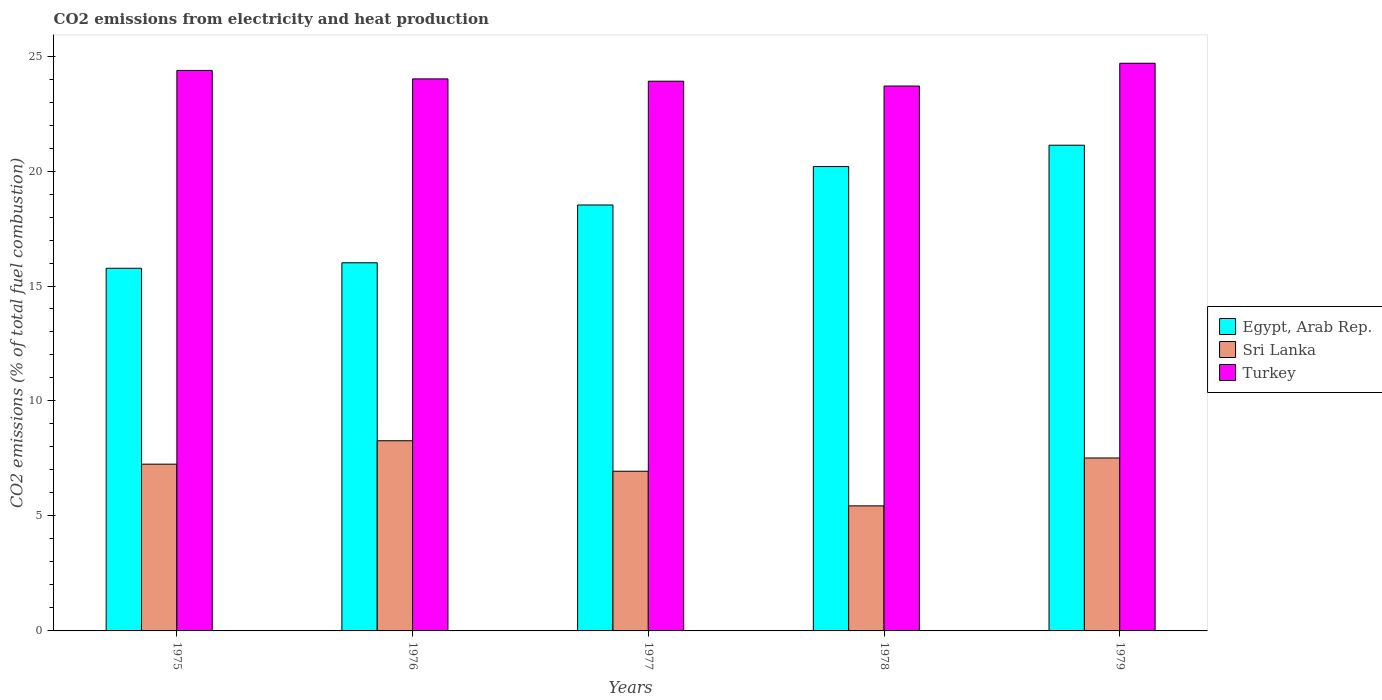Are the number of bars on each tick of the X-axis equal?
Your response must be concise. Yes. What is the label of the 2nd group of bars from the left?
Make the answer very short. 1976. What is the amount of CO2 emitted in Sri Lanka in 1979?
Ensure brevity in your answer.  7.52. Across all years, what is the maximum amount of CO2 emitted in Turkey?
Keep it short and to the point. 24.69. Across all years, what is the minimum amount of CO2 emitted in Turkey?
Provide a succinct answer. 23.7. In which year was the amount of CO2 emitted in Egypt, Arab Rep. maximum?
Ensure brevity in your answer.  1979. In which year was the amount of CO2 emitted in Turkey minimum?
Give a very brief answer. 1978. What is the total amount of CO2 emitted in Turkey in the graph?
Keep it short and to the point. 120.67. What is the difference between the amount of CO2 emitted in Turkey in 1976 and that in 1977?
Make the answer very short. 0.1. What is the difference between the amount of CO2 emitted in Egypt, Arab Rep. in 1977 and the amount of CO2 emitted in Sri Lanka in 1978?
Provide a succinct answer. 13.08. What is the average amount of CO2 emitted in Turkey per year?
Provide a short and direct response. 24.13. In the year 1975, what is the difference between the amount of CO2 emitted in Turkey and amount of CO2 emitted in Sri Lanka?
Ensure brevity in your answer.  17.12. What is the ratio of the amount of CO2 emitted in Egypt, Arab Rep. in 1977 to that in 1979?
Make the answer very short. 0.88. Is the amount of CO2 emitted in Sri Lanka in 1977 less than that in 1979?
Your answer should be very brief. Yes. What is the difference between the highest and the second highest amount of CO2 emitted in Sri Lanka?
Make the answer very short. 0.75. What is the difference between the highest and the lowest amount of CO2 emitted in Egypt, Arab Rep.?
Make the answer very short. 5.35. In how many years, is the amount of CO2 emitted in Egypt, Arab Rep. greater than the average amount of CO2 emitted in Egypt, Arab Rep. taken over all years?
Make the answer very short. 3. What does the 1st bar from the left in 1975 represents?
Ensure brevity in your answer.  Egypt, Arab Rep. Does the graph contain any zero values?
Ensure brevity in your answer.  No. Does the graph contain grids?
Provide a short and direct response. No. Where does the legend appear in the graph?
Offer a very short reply. Center right. How are the legend labels stacked?
Make the answer very short. Vertical. What is the title of the graph?
Make the answer very short. CO2 emissions from electricity and heat production. What is the label or title of the X-axis?
Provide a succinct answer. Years. What is the label or title of the Y-axis?
Your answer should be compact. CO2 emissions (% of total fuel combustion). What is the CO2 emissions (% of total fuel combustion) of Egypt, Arab Rep. in 1975?
Give a very brief answer. 15.77. What is the CO2 emissions (% of total fuel combustion) in Sri Lanka in 1975?
Ensure brevity in your answer.  7.25. What is the CO2 emissions (% of total fuel combustion) in Turkey in 1975?
Provide a short and direct response. 24.38. What is the CO2 emissions (% of total fuel combustion) in Egypt, Arab Rep. in 1976?
Your response must be concise. 16.01. What is the CO2 emissions (% of total fuel combustion) of Sri Lanka in 1976?
Provide a succinct answer. 8.27. What is the CO2 emissions (% of total fuel combustion) in Turkey in 1976?
Offer a very short reply. 24.01. What is the CO2 emissions (% of total fuel combustion) in Egypt, Arab Rep. in 1977?
Provide a succinct answer. 18.52. What is the CO2 emissions (% of total fuel combustion) of Sri Lanka in 1977?
Give a very brief answer. 6.94. What is the CO2 emissions (% of total fuel combustion) in Turkey in 1977?
Offer a terse response. 23.91. What is the CO2 emissions (% of total fuel combustion) in Egypt, Arab Rep. in 1978?
Your answer should be very brief. 20.19. What is the CO2 emissions (% of total fuel combustion) of Sri Lanka in 1978?
Offer a very short reply. 5.44. What is the CO2 emissions (% of total fuel combustion) of Turkey in 1978?
Your answer should be very brief. 23.7. What is the CO2 emissions (% of total fuel combustion) of Egypt, Arab Rep. in 1979?
Offer a very short reply. 21.12. What is the CO2 emissions (% of total fuel combustion) of Sri Lanka in 1979?
Your answer should be very brief. 7.52. What is the CO2 emissions (% of total fuel combustion) of Turkey in 1979?
Your answer should be compact. 24.69. Across all years, what is the maximum CO2 emissions (% of total fuel combustion) in Egypt, Arab Rep.?
Your answer should be compact. 21.12. Across all years, what is the maximum CO2 emissions (% of total fuel combustion) of Sri Lanka?
Your answer should be compact. 8.27. Across all years, what is the maximum CO2 emissions (% of total fuel combustion) in Turkey?
Your answer should be very brief. 24.69. Across all years, what is the minimum CO2 emissions (% of total fuel combustion) in Egypt, Arab Rep.?
Give a very brief answer. 15.77. Across all years, what is the minimum CO2 emissions (% of total fuel combustion) in Sri Lanka?
Ensure brevity in your answer.  5.44. Across all years, what is the minimum CO2 emissions (% of total fuel combustion) in Turkey?
Give a very brief answer. 23.7. What is the total CO2 emissions (% of total fuel combustion) of Egypt, Arab Rep. in the graph?
Your response must be concise. 91.62. What is the total CO2 emissions (% of total fuel combustion) in Sri Lanka in the graph?
Offer a very short reply. 35.43. What is the total CO2 emissions (% of total fuel combustion) in Turkey in the graph?
Make the answer very short. 120.67. What is the difference between the CO2 emissions (% of total fuel combustion) in Egypt, Arab Rep. in 1975 and that in 1976?
Provide a succinct answer. -0.24. What is the difference between the CO2 emissions (% of total fuel combustion) in Sri Lanka in 1975 and that in 1976?
Offer a very short reply. -1.02. What is the difference between the CO2 emissions (% of total fuel combustion) of Turkey in 1975 and that in 1976?
Your answer should be very brief. 0.37. What is the difference between the CO2 emissions (% of total fuel combustion) of Egypt, Arab Rep. in 1975 and that in 1977?
Make the answer very short. -2.75. What is the difference between the CO2 emissions (% of total fuel combustion) in Sri Lanka in 1975 and that in 1977?
Offer a terse response. 0.31. What is the difference between the CO2 emissions (% of total fuel combustion) in Turkey in 1975 and that in 1977?
Your answer should be compact. 0.47. What is the difference between the CO2 emissions (% of total fuel combustion) in Egypt, Arab Rep. in 1975 and that in 1978?
Provide a succinct answer. -4.42. What is the difference between the CO2 emissions (% of total fuel combustion) in Sri Lanka in 1975 and that in 1978?
Your response must be concise. 1.81. What is the difference between the CO2 emissions (% of total fuel combustion) in Turkey in 1975 and that in 1978?
Your response must be concise. 0.68. What is the difference between the CO2 emissions (% of total fuel combustion) in Egypt, Arab Rep. in 1975 and that in 1979?
Give a very brief answer. -5.35. What is the difference between the CO2 emissions (% of total fuel combustion) in Sri Lanka in 1975 and that in 1979?
Your answer should be very brief. -0.27. What is the difference between the CO2 emissions (% of total fuel combustion) of Turkey in 1975 and that in 1979?
Ensure brevity in your answer.  -0.31. What is the difference between the CO2 emissions (% of total fuel combustion) in Egypt, Arab Rep. in 1976 and that in 1977?
Keep it short and to the point. -2.51. What is the difference between the CO2 emissions (% of total fuel combustion) in Sri Lanka in 1976 and that in 1977?
Ensure brevity in your answer.  1.33. What is the difference between the CO2 emissions (% of total fuel combustion) in Turkey in 1976 and that in 1977?
Give a very brief answer. 0.1. What is the difference between the CO2 emissions (% of total fuel combustion) of Egypt, Arab Rep. in 1976 and that in 1978?
Your answer should be compact. -4.19. What is the difference between the CO2 emissions (% of total fuel combustion) in Sri Lanka in 1976 and that in 1978?
Offer a terse response. 2.83. What is the difference between the CO2 emissions (% of total fuel combustion) of Turkey in 1976 and that in 1978?
Keep it short and to the point. 0.31. What is the difference between the CO2 emissions (% of total fuel combustion) of Egypt, Arab Rep. in 1976 and that in 1979?
Make the answer very short. -5.11. What is the difference between the CO2 emissions (% of total fuel combustion) in Sri Lanka in 1976 and that in 1979?
Ensure brevity in your answer.  0.75. What is the difference between the CO2 emissions (% of total fuel combustion) in Turkey in 1976 and that in 1979?
Ensure brevity in your answer.  -0.68. What is the difference between the CO2 emissions (% of total fuel combustion) in Egypt, Arab Rep. in 1977 and that in 1978?
Offer a terse response. -1.67. What is the difference between the CO2 emissions (% of total fuel combustion) in Sri Lanka in 1977 and that in 1978?
Your answer should be very brief. 1.51. What is the difference between the CO2 emissions (% of total fuel combustion) of Turkey in 1977 and that in 1978?
Ensure brevity in your answer.  0.21. What is the difference between the CO2 emissions (% of total fuel combustion) in Egypt, Arab Rep. in 1977 and that in 1979?
Provide a succinct answer. -2.6. What is the difference between the CO2 emissions (% of total fuel combustion) in Sri Lanka in 1977 and that in 1979?
Give a very brief answer. -0.58. What is the difference between the CO2 emissions (% of total fuel combustion) of Turkey in 1977 and that in 1979?
Ensure brevity in your answer.  -0.78. What is the difference between the CO2 emissions (% of total fuel combustion) of Egypt, Arab Rep. in 1978 and that in 1979?
Offer a very short reply. -0.93. What is the difference between the CO2 emissions (% of total fuel combustion) in Sri Lanka in 1978 and that in 1979?
Keep it short and to the point. -2.08. What is the difference between the CO2 emissions (% of total fuel combustion) in Turkey in 1978 and that in 1979?
Provide a succinct answer. -0.99. What is the difference between the CO2 emissions (% of total fuel combustion) of Egypt, Arab Rep. in 1975 and the CO2 emissions (% of total fuel combustion) of Sri Lanka in 1976?
Your answer should be very brief. 7.5. What is the difference between the CO2 emissions (% of total fuel combustion) of Egypt, Arab Rep. in 1975 and the CO2 emissions (% of total fuel combustion) of Turkey in 1976?
Provide a short and direct response. -8.24. What is the difference between the CO2 emissions (% of total fuel combustion) of Sri Lanka in 1975 and the CO2 emissions (% of total fuel combustion) of Turkey in 1976?
Your response must be concise. -16.76. What is the difference between the CO2 emissions (% of total fuel combustion) in Egypt, Arab Rep. in 1975 and the CO2 emissions (% of total fuel combustion) in Sri Lanka in 1977?
Provide a succinct answer. 8.83. What is the difference between the CO2 emissions (% of total fuel combustion) in Egypt, Arab Rep. in 1975 and the CO2 emissions (% of total fuel combustion) in Turkey in 1977?
Offer a terse response. -8.14. What is the difference between the CO2 emissions (% of total fuel combustion) of Sri Lanka in 1975 and the CO2 emissions (% of total fuel combustion) of Turkey in 1977?
Offer a very short reply. -16.65. What is the difference between the CO2 emissions (% of total fuel combustion) in Egypt, Arab Rep. in 1975 and the CO2 emissions (% of total fuel combustion) in Sri Lanka in 1978?
Your response must be concise. 10.33. What is the difference between the CO2 emissions (% of total fuel combustion) in Egypt, Arab Rep. in 1975 and the CO2 emissions (% of total fuel combustion) in Turkey in 1978?
Your answer should be compact. -7.93. What is the difference between the CO2 emissions (% of total fuel combustion) of Sri Lanka in 1975 and the CO2 emissions (% of total fuel combustion) of Turkey in 1978?
Offer a very short reply. -16.44. What is the difference between the CO2 emissions (% of total fuel combustion) in Egypt, Arab Rep. in 1975 and the CO2 emissions (% of total fuel combustion) in Sri Lanka in 1979?
Offer a very short reply. 8.25. What is the difference between the CO2 emissions (% of total fuel combustion) in Egypt, Arab Rep. in 1975 and the CO2 emissions (% of total fuel combustion) in Turkey in 1979?
Provide a short and direct response. -8.92. What is the difference between the CO2 emissions (% of total fuel combustion) of Sri Lanka in 1975 and the CO2 emissions (% of total fuel combustion) of Turkey in 1979?
Offer a terse response. -17.43. What is the difference between the CO2 emissions (% of total fuel combustion) of Egypt, Arab Rep. in 1976 and the CO2 emissions (% of total fuel combustion) of Sri Lanka in 1977?
Keep it short and to the point. 9.06. What is the difference between the CO2 emissions (% of total fuel combustion) in Egypt, Arab Rep. in 1976 and the CO2 emissions (% of total fuel combustion) in Turkey in 1977?
Provide a short and direct response. -7.9. What is the difference between the CO2 emissions (% of total fuel combustion) in Sri Lanka in 1976 and the CO2 emissions (% of total fuel combustion) in Turkey in 1977?
Keep it short and to the point. -15.64. What is the difference between the CO2 emissions (% of total fuel combustion) of Egypt, Arab Rep. in 1976 and the CO2 emissions (% of total fuel combustion) of Sri Lanka in 1978?
Ensure brevity in your answer.  10.57. What is the difference between the CO2 emissions (% of total fuel combustion) of Egypt, Arab Rep. in 1976 and the CO2 emissions (% of total fuel combustion) of Turkey in 1978?
Offer a terse response. -7.69. What is the difference between the CO2 emissions (% of total fuel combustion) of Sri Lanka in 1976 and the CO2 emissions (% of total fuel combustion) of Turkey in 1978?
Make the answer very short. -15.43. What is the difference between the CO2 emissions (% of total fuel combustion) in Egypt, Arab Rep. in 1976 and the CO2 emissions (% of total fuel combustion) in Sri Lanka in 1979?
Provide a succinct answer. 8.49. What is the difference between the CO2 emissions (% of total fuel combustion) in Egypt, Arab Rep. in 1976 and the CO2 emissions (% of total fuel combustion) in Turkey in 1979?
Ensure brevity in your answer.  -8.68. What is the difference between the CO2 emissions (% of total fuel combustion) of Sri Lanka in 1976 and the CO2 emissions (% of total fuel combustion) of Turkey in 1979?
Your response must be concise. -16.42. What is the difference between the CO2 emissions (% of total fuel combustion) of Egypt, Arab Rep. in 1977 and the CO2 emissions (% of total fuel combustion) of Sri Lanka in 1978?
Your response must be concise. 13.09. What is the difference between the CO2 emissions (% of total fuel combustion) of Egypt, Arab Rep. in 1977 and the CO2 emissions (% of total fuel combustion) of Turkey in 1978?
Provide a short and direct response. -5.17. What is the difference between the CO2 emissions (% of total fuel combustion) of Sri Lanka in 1977 and the CO2 emissions (% of total fuel combustion) of Turkey in 1978?
Offer a very short reply. -16.75. What is the difference between the CO2 emissions (% of total fuel combustion) of Egypt, Arab Rep. in 1977 and the CO2 emissions (% of total fuel combustion) of Sri Lanka in 1979?
Your answer should be very brief. 11. What is the difference between the CO2 emissions (% of total fuel combustion) of Egypt, Arab Rep. in 1977 and the CO2 emissions (% of total fuel combustion) of Turkey in 1979?
Your answer should be compact. -6.16. What is the difference between the CO2 emissions (% of total fuel combustion) of Sri Lanka in 1977 and the CO2 emissions (% of total fuel combustion) of Turkey in 1979?
Keep it short and to the point. -17.74. What is the difference between the CO2 emissions (% of total fuel combustion) in Egypt, Arab Rep. in 1978 and the CO2 emissions (% of total fuel combustion) in Sri Lanka in 1979?
Provide a short and direct response. 12.67. What is the difference between the CO2 emissions (% of total fuel combustion) of Egypt, Arab Rep. in 1978 and the CO2 emissions (% of total fuel combustion) of Turkey in 1979?
Offer a very short reply. -4.49. What is the difference between the CO2 emissions (% of total fuel combustion) of Sri Lanka in 1978 and the CO2 emissions (% of total fuel combustion) of Turkey in 1979?
Your answer should be compact. -19.25. What is the average CO2 emissions (% of total fuel combustion) of Egypt, Arab Rep. per year?
Offer a very short reply. 18.32. What is the average CO2 emissions (% of total fuel combustion) in Sri Lanka per year?
Offer a very short reply. 7.09. What is the average CO2 emissions (% of total fuel combustion) in Turkey per year?
Your answer should be compact. 24.13. In the year 1975, what is the difference between the CO2 emissions (% of total fuel combustion) in Egypt, Arab Rep. and CO2 emissions (% of total fuel combustion) in Sri Lanka?
Provide a succinct answer. 8.52. In the year 1975, what is the difference between the CO2 emissions (% of total fuel combustion) of Egypt, Arab Rep. and CO2 emissions (% of total fuel combustion) of Turkey?
Give a very brief answer. -8.6. In the year 1975, what is the difference between the CO2 emissions (% of total fuel combustion) in Sri Lanka and CO2 emissions (% of total fuel combustion) in Turkey?
Ensure brevity in your answer.  -17.12. In the year 1976, what is the difference between the CO2 emissions (% of total fuel combustion) of Egypt, Arab Rep. and CO2 emissions (% of total fuel combustion) of Sri Lanka?
Provide a short and direct response. 7.74. In the year 1976, what is the difference between the CO2 emissions (% of total fuel combustion) in Egypt, Arab Rep. and CO2 emissions (% of total fuel combustion) in Turkey?
Offer a very short reply. -8. In the year 1976, what is the difference between the CO2 emissions (% of total fuel combustion) of Sri Lanka and CO2 emissions (% of total fuel combustion) of Turkey?
Make the answer very short. -15.74. In the year 1977, what is the difference between the CO2 emissions (% of total fuel combustion) of Egypt, Arab Rep. and CO2 emissions (% of total fuel combustion) of Sri Lanka?
Your response must be concise. 11.58. In the year 1977, what is the difference between the CO2 emissions (% of total fuel combustion) of Egypt, Arab Rep. and CO2 emissions (% of total fuel combustion) of Turkey?
Offer a very short reply. -5.38. In the year 1977, what is the difference between the CO2 emissions (% of total fuel combustion) in Sri Lanka and CO2 emissions (% of total fuel combustion) in Turkey?
Your response must be concise. -16.96. In the year 1978, what is the difference between the CO2 emissions (% of total fuel combustion) of Egypt, Arab Rep. and CO2 emissions (% of total fuel combustion) of Sri Lanka?
Your response must be concise. 14.76. In the year 1978, what is the difference between the CO2 emissions (% of total fuel combustion) of Egypt, Arab Rep. and CO2 emissions (% of total fuel combustion) of Turkey?
Your answer should be compact. -3.5. In the year 1978, what is the difference between the CO2 emissions (% of total fuel combustion) in Sri Lanka and CO2 emissions (% of total fuel combustion) in Turkey?
Your response must be concise. -18.26. In the year 1979, what is the difference between the CO2 emissions (% of total fuel combustion) of Egypt, Arab Rep. and CO2 emissions (% of total fuel combustion) of Sri Lanka?
Give a very brief answer. 13.6. In the year 1979, what is the difference between the CO2 emissions (% of total fuel combustion) of Egypt, Arab Rep. and CO2 emissions (% of total fuel combustion) of Turkey?
Give a very brief answer. -3.56. In the year 1979, what is the difference between the CO2 emissions (% of total fuel combustion) of Sri Lanka and CO2 emissions (% of total fuel combustion) of Turkey?
Your response must be concise. -17.17. What is the ratio of the CO2 emissions (% of total fuel combustion) of Egypt, Arab Rep. in 1975 to that in 1976?
Provide a succinct answer. 0.99. What is the ratio of the CO2 emissions (% of total fuel combustion) in Sri Lanka in 1975 to that in 1976?
Ensure brevity in your answer.  0.88. What is the ratio of the CO2 emissions (% of total fuel combustion) in Turkey in 1975 to that in 1976?
Your answer should be compact. 1.02. What is the ratio of the CO2 emissions (% of total fuel combustion) in Egypt, Arab Rep. in 1975 to that in 1977?
Provide a short and direct response. 0.85. What is the ratio of the CO2 emissions (% of total fuel combustion) of Sri Lanka in 1975 to that in 1977?
Keep it short and to the point. 1.04. What is the ratio of the CO2 emissions (% of total fuel combustion) of Turkey in 1975 to that in 1977?
Ensure brevity in your answer.  1.02. What is the ratio of the CO2 emissions (% of total fuel combustion) in Egypt, Arab Rep. in 1975 to that in 1978?
Keep it short and to the point. 0.78. What is the ratio of the CO2 emissions (% of total fuel combustion) in Sri Lanka in 1975 to that in 1978?
Your answer should be compact. 1.33. What is the ratio of the CO2 emissions (% of total fuel combustion) in Turkey in 1975 to that in 1978?
Provide a succinct answer. 1.03. What is the ratio of the CO2 emissions (% of total fuel combustion) in Egypt, Arab Rep. in 1975 to that in 1979?
Provide a succinct answer. 0.75. What is the ratio of the CO2 emissions (% of total fuel combustion) of Sri Lanka in 1975 to that in 1979?
Provide a succinct answer. 0.96. What is the ratio of the CO2 emissions (% of total fuel combustion) of Turkey in 1975 to that in 1979?
Offer a terse response. 0.99. What is the ratio of the CO2 emissions (% of total fuel combustion) in Egypt, Arab Rep. in 1976 to that in 1977?
Your answer should be compact. 0.86. What is the ratio of the CO2 emissions (% of total fuel combustion) in Sri Lanka in 1976 to that in 1977?
Give a very brief answer. 1.19. What is the ratio of the CO2 emissions (% of total fuel combustion) of Egypt, Arab Rep. in 1976 to that in 1978?
Your answer should be very brief. 0.79. What is the ratio of the CO2 emissions (% of total fuel combustion) of Sri Lanka in 1976 to that in 1978?
Offer a very short reply. 1.52. What is the ratio of the CO2 emissions (% of total fuel combustion) of Turkey in 1976 to that in 1978?
Your answer should be compact. 1.01. What is the ratio of the CO2 emissions (% of total fuel combustion) of Egypt, Arab Rep. in 1976 to that in 1979?
Your answer should be compact. 0.76. What is the ratio of the CO2 emissions (% of total fuel combustion) in Sri Lanka in 1976 to that in 1979?
Offer a terse response. 1.1. What is the ratio of the CO2 emissions (% of total fuel combustion) in Turkey in 1976 to that in 1979?
Offer a terse response. 0.97. What is the ratio of the CO2 emissions (% of total fuel combustion) in Egypt, Arab Rep. in 1977 to that in 1978?
Offer a terse response. 0.92. What is the ratio of the CO2 emissions (% of total fuel combustion) in Sri Lanka in 1977 to that in 1978?
Keep it short and to the point. 1.28. What is the ratio of the CO2 emissions (% of total fuel combustion) of Turkey in 1977 to that in 1978?
Ensure brevity in your answer.  1.01. What is the ratio of the CO2 emissions (% of total fuel combustion) of Egypt, Arab Rep. in 1977 to that in 1979?
Provide a succinct answer. 0.88. What is the ratio of the CO2 emissions (% of total fuel combustion) in Sri Lanka in 1977 to that in 1979?
Ensure brevity in your answer.  0.92. What is the ratio of the CO2 emissions (% of total fuel combustion) of Turkey in 1977 to that in 1979?
Provide a short and direct response. 0.97. What is the ratio of the CO2 emissions (% of total fuel combustion) of Egypt, Arab Rep. in 1978 to that in 1979?
Give a very brief answer. 0.96. What is the ratio of the CO2 emissions (% of total fuel combustion) in Sri Lanka in 1978 to that in 1979?
Ensure brevity in your answer.  0.72. What is the ratio of the CO2 emissions (% of total fuel combustion) in Turkey in 1978 to that in 1979?
Keep it short and to the point. 0.96. What is the difference between the highest and the second highest CO2 emissions (% of total fuel combustion) in Egypt, Arab Rep.?
Keep it short and to the point. 0.93. What is the difference between the highest and the second highest CO2 emissions (% of total fuel combustion) in Sri Lanka?
Your response must be concise. 0.75. What is the difference between the highest and the second highest CO2 emissions (% of total fuel combustion) of Turkey?
Your answer should be very brief. 0.31. What is the difference between the highest and the lowest CO2 emissions (% of total fuel combustion) in Egypt, Arab Rep.?
Provide a succinct answer. 5.35. What is the difference between the highest and the lowest CO2 emissions (% of total fuel combustion) of Sri Lanka?
Your answer should be very brief. 2.83. What is the difference between the highest and the lowest CO2 emissions (% of total fuel combustion) in Turkey?
Provide a short and direct response. 0.99. 